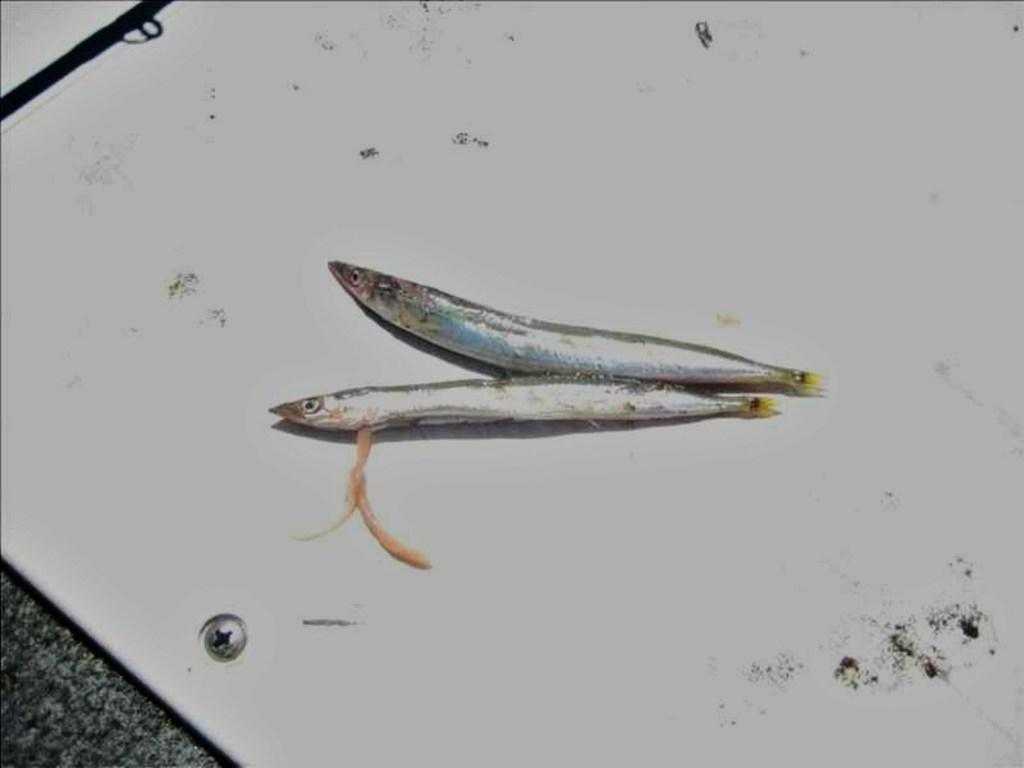What type of animals are present in the image? There are fishes in the image. Can you describe the object on which the fishes are located? Unfortunately, the facts provided do not specify the type of object on which the fishes are located. What type of doll is present on the island in the image? There is no doll or island mentioned in the provided facts, so we cannot answer this question. 